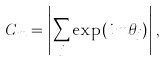Convert formula to latex. <formula><loc_0><loc_0><loc_500><loc_500>C _ { m } = \left | \sum _ { j } \exp ( i \, m \theta _ { j } ) \right | ,</formula> 